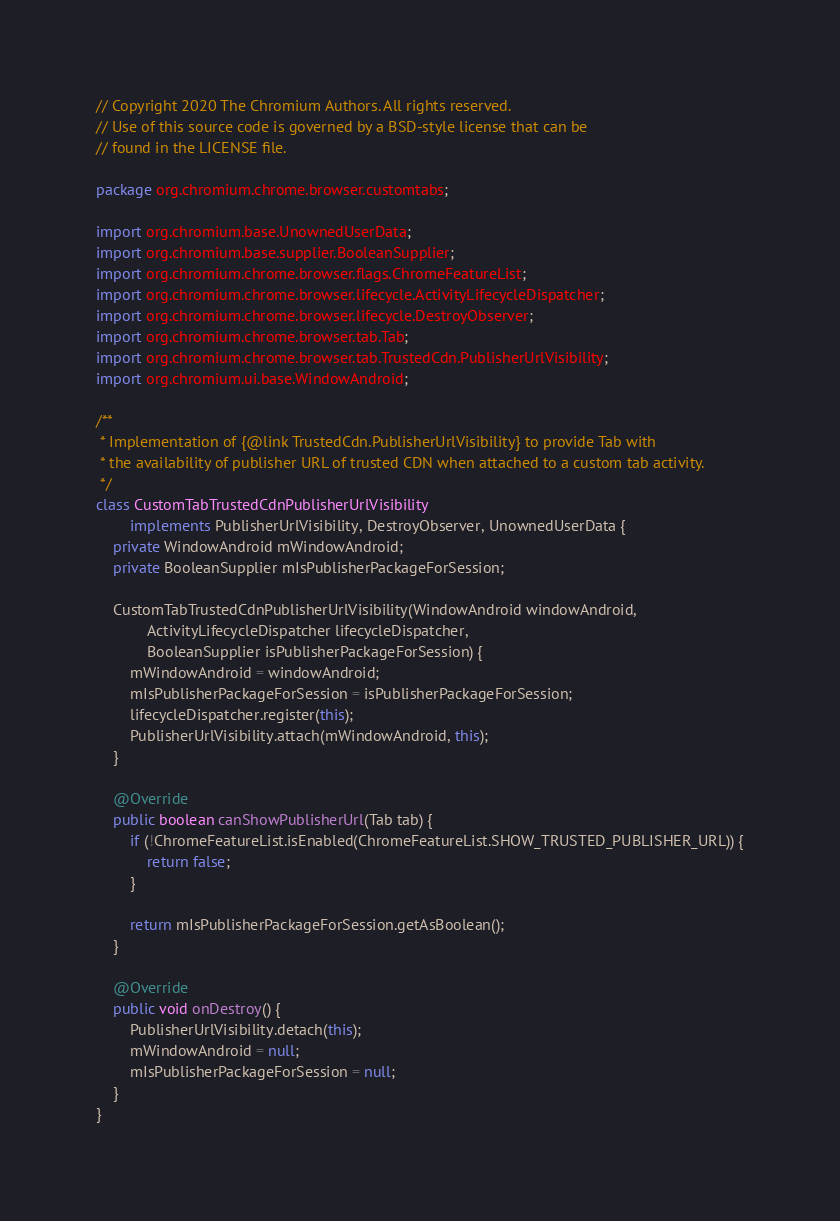<code> <loc_0><loc_0><loc_500><loc_500><_Java_>// Copyright 2020 The Chromium Authors. All rights reserved.
// Use of this source code is governed by a BSD-style license that can be
// found in the LICENSE file.

package org.chromium.chrome.browser.customtabs;

import org.chromium.base.UnownedUserData;
import org.chromium.base.supplier.BooleanSupplier;
import org.chromium.chrome.browser.flags.ChromeFeatureList;
import org.chromium.chrome.browser.lifecycle.ActivityLifecycleDispatcher;
import org.chromium.chrome.browser.lifecycle.DestroyObserver;
import org.chromium.chrome.browser.tab.Tab;
import org.chromium.chrome.browser.tab.TrustedCdn.PublisherUrlVisibility;
import org.chromium.ui.base.WindowAndroid;

/**
 * Implementation of {@link TrustedCdn.PublisherUrlVisibility} to provide Tab with
 * the availability of publisher URL of trusted CDN when attached to a custom tab activity.
 */
class CustomTabTrustedCdnPublisherUrlVisibility
        implements PublisherUrlVisibility, DestroyObserver, UnownedUserData {
    private WindowAndroid mWindowAndroid;
    private BooleanSupplier mIsPublisherPackageForSession;

    CustomTabTrustedCdnPublisherUrlVisibility(WindowAndroid windowAndroid,
            ActivityLifecycleDispatcher lifecycleDispatcher,
            BooleanSupplier isPublisherPackageForSession) {
        mWindowAndroid = windowAndroid;
        mIsPublisherPackageForSession = isPublisherPackageForSession;
        lifecycleDispatcher.register(this);
        PublisherUrlVisibility.attach(mWindowAndroid, this);
    }

    @Override
    public boolean canShowPublisherUrl(Tab tab) {
        if (!ChromeFeatureList.isEnabled(ChromeFeatureList.SHOW_TRUSTED_PUBLISHER_URL)) {
            return false;
        }

        return mIsPublisherPackageForSession.getAsBoolean();
    }

    @Override
    public void onDestroy() {
        PublisherUrlVisibility.detach(this);
        mWindowAndroid = null;
        mIsPublisherPackageForSession = null;
    }
}
</code> 